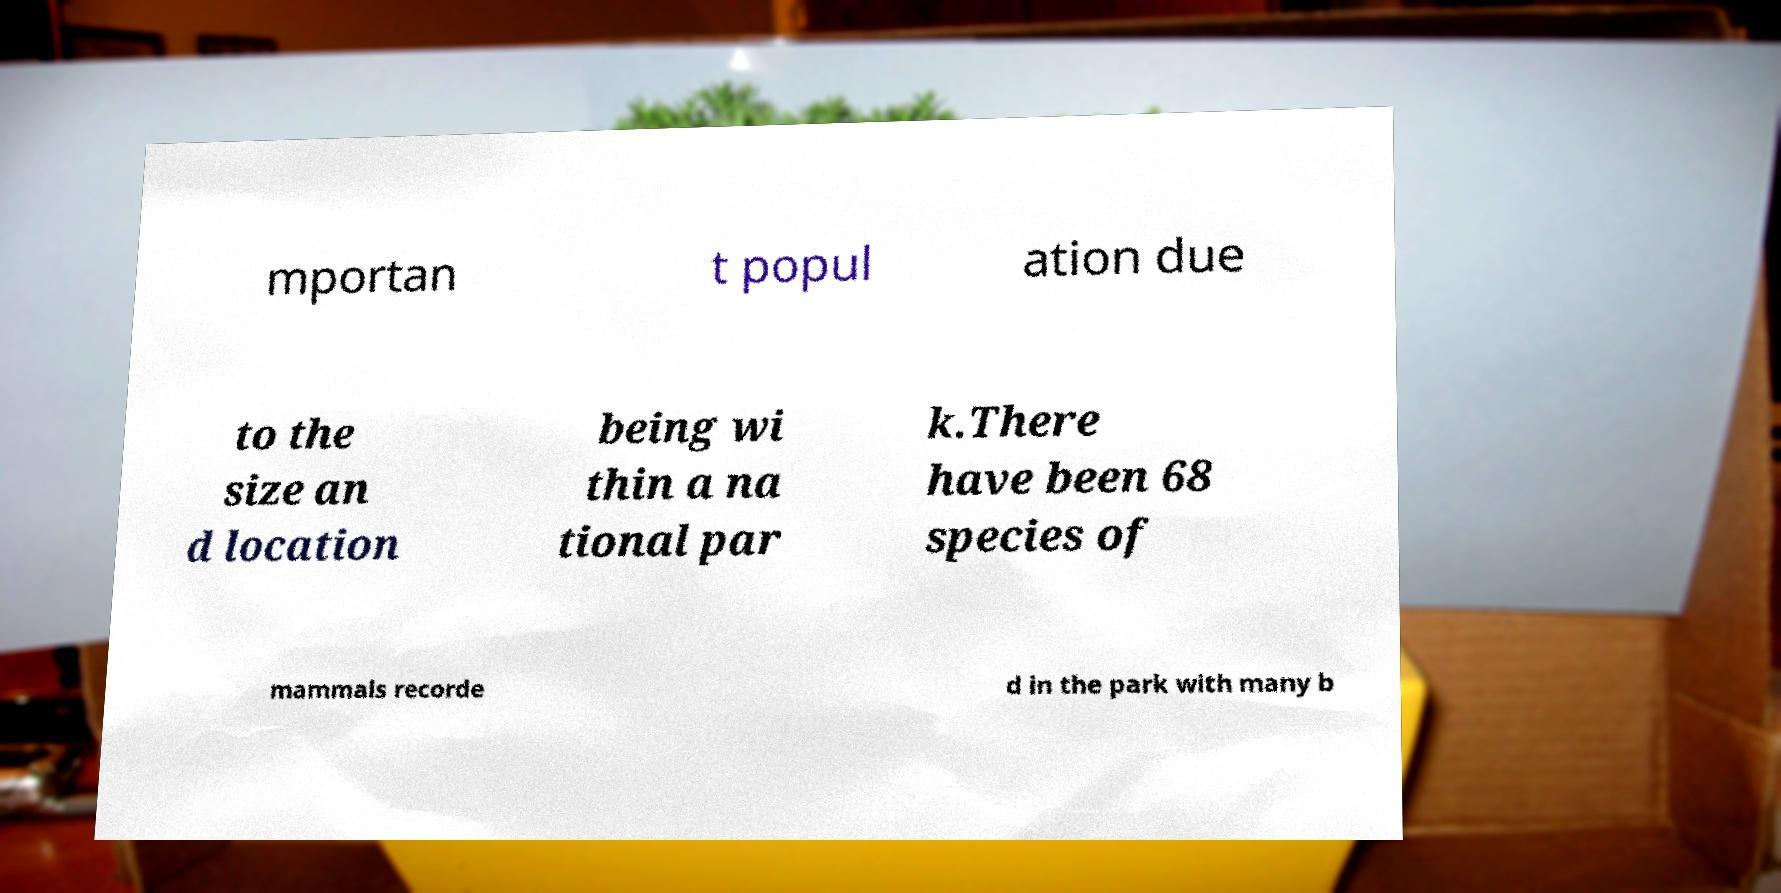There's text embedded in this image that I need extracted. Can you transcribe it verbatim? mportan t popul ation due to the size an d location being wi thin a na tional par k.There have been 68 species of mammals recorde d in the park with many b 